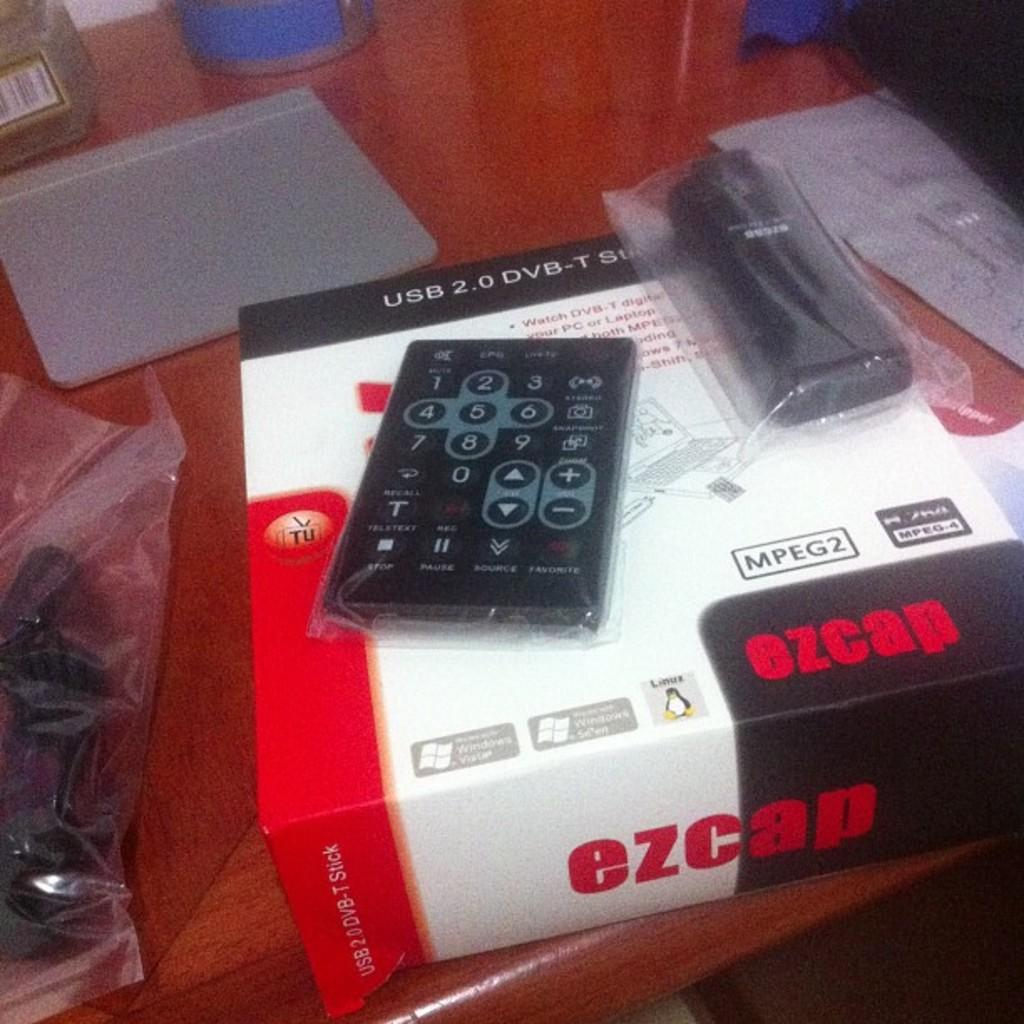Provide a one-sentence caption for the provided image. An EZCAP DVB player box with the remote on the top of the box, it is placed on a desk. 